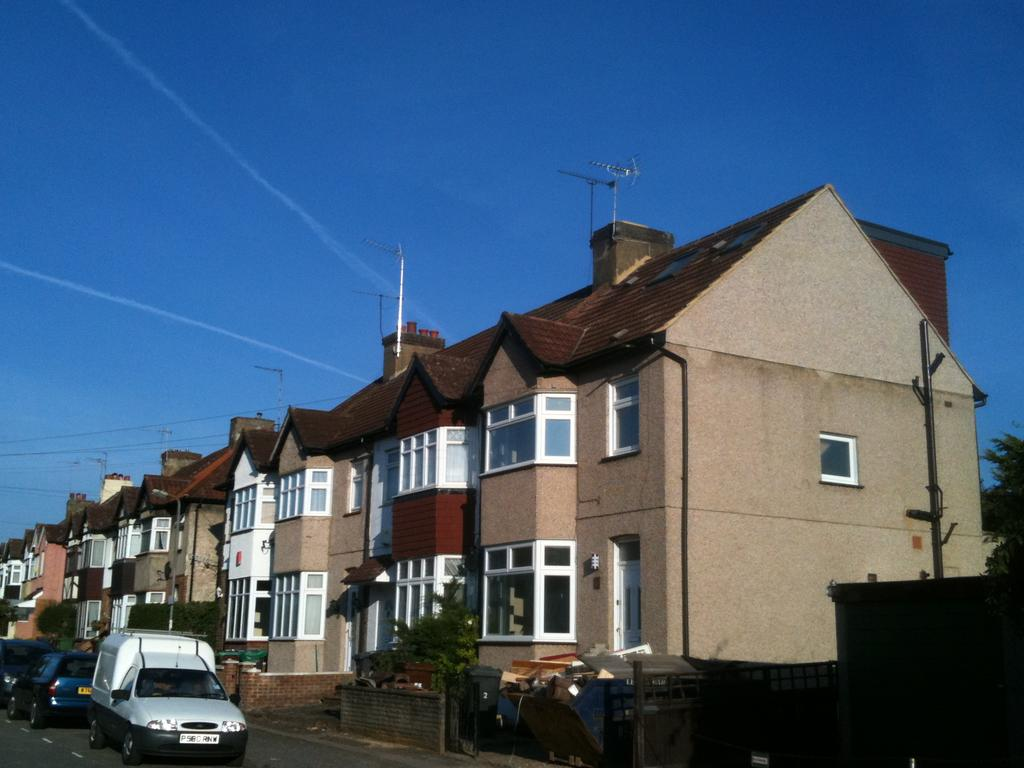What type of structures can be seen in the image? There are many houses in the image. What else is visible in front of the houses? There are vehicles in front of the houses. How many feet are visible on the houses in the image? There are no feet visible on the houses in the image. What type of building is shown in the image? The image does not show a specific building; it shows many houses. Is there a pie being served in the image? There is no pie present in the image. 